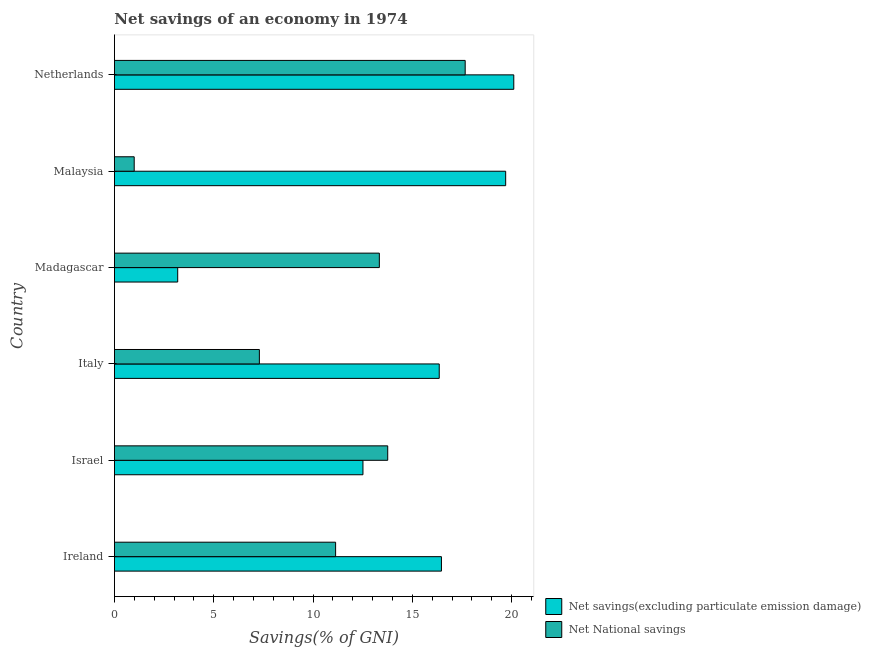How many groups of bars are there?
Offer a terse response. 6. Are the number of bars per tick equal to the number of legend labels?
Your answer should be very brief. Yes. How many bars are there on the 4th tick from the top?
Provide a short and direct response. 2. How many bars are there on the 6th tick from the bottom?
Provide a succinct answer. 2. What is the label of the 6th group of bars from the top?
Your response must be concise. Ireland. In how many cases, is the number of bars for a given country not equal to the number of legend labels?
Provide a short and direct response. 0. What is the net savings(excluding particulate emission damage) in Madagascar?
Make the answer very short. 3.19. Across all countries, what is the maximum net national savings?
Keep it short and to the point. 17.66. Across all countries, what is the minimum net national savings?
Keep it short and to the point. 1. In which country was the net savings(excluding particulate emission damage) maximum?
Offer a very short reply. Netherlands. In which country was the net national savings minimum?
Your response must be concise. Malaysia. What is the total net national savings in the graph?
Your answer should be compact. 64.18. What is the difference between the net savings(excluding particulate emission damage) in Ireland and that in Israel?
Keep it short and to the point. 3.95. What is the difference between the net savings(excluding particulate emission damage) in Malaysia and the net national savings in Ireland?
Offer a very short reply. 8.56. What is the average net savings(excluding particulate emission damage) per country?
Ensure brevity in your answer.  14.72. What is the difference between the net national savings and net savings(excluding particulate emission damage) in Israel?
Give a very brief answer. 1.25. In how many countries, is the net savings(excluding particulate emission damage) greater than 2 %?
Make the answer very short. 6. What is the ratio of the net savings(excluding particulate emission damage) in Ireland to that in Malaysia?
Give a very brief answer. 0.84. Is the net savings(excluding particulate emission damage) in Ireland less than that in Italy?
Keep it short and to the point. No. What is the difference between the highest and the second highest net savings(excluding particulate emission damage)?
Your answer should be compact. 0.41. What is the difference between the highest and the lowest net national savings?
Give a very brief answer. 16.66. What does the 1st bar from the top in Madagascar represents?
Ensure brevity in your answer.  Net National savings. What does the 2nd bar from the bottom in Netherlands represents?
Keep it short and to the point. Net National savings. Are the values on the major ticks of X-axis written in scientific E-notation?
Offer a very short reply. No. Does the graph contain any zero values?
Your answer should be compact. No. What is the title of the graph?
Provide a succinct answer. Net savings of an economy in 1974. Does "Primary completion rate" appear as one of the legend labels in the graph?
Your response must be concise. No. What is the label or title of the X-axis?
Provide a short and direct response. Savings(% of GNI). What is the Savings(% of GNI) in Net savings(excluding particulate emission damage) in Ireland?
Provide a short and direct response. 16.46. What is the Savings(% of GNI) in Net National savings in Ireland?
Give a very brief answer. 11.14. What is the Savings(% of GNI) in Net savings(excluding particulate emission damage) in Israel?
Offer a terse response. 12.51. What is the Savings(% of GNI) of Net National savings in Israel?
Your response must be concise. 13.76. What is the Savings(% of GNI) of Net savings(excluding particulate emission damage) in Italy?
Provide a short and direct response. 16.35. What is the Savings(% of GNI) of Net National savings in Italy?
Your response must be concise. 7.3. What is the Savings(% of GNI) in Net savings(excluding particulate emission damage) in Madagascar?
Your answer should be compact. 3.19. What is the Savings(% of GNI) in Net National savings in Madagascar?
Offer a terse response. 13.34. What is the Savings(% of GNI) in Net savings(excluding particulate emission damage) in Malaysia?
Give a very brief answer. 19.7. What is the Savings(% of GNI) in Net National savings in Malaysia?
Ensure brevity in your answer.  1. What is the Savings(% of GNI) in Net savings(excluding particulate emission damage) in Netherlands?
Provide a short and direct response. 20.1. What is the Savings(% of GNI) in Net National savings in Netherlands?
Provide a short and direct response. 17.66. Across all countries, what is the maximum Savings(% of GNI) in Net savings(excluding particulate emission damage)?
Your response must be concise. 20.1. Across all countries, what is the maximum Savings(% of GNI) of Net National savings?
Your response must be concise. 17.66. Across all countries, what is the minimum Savings(% of GNI) of Net savings(excluding particulate emission damage)?
Keep it short and to the point. 3.19. Across all countries, what is the minimum Savings(% of GNI) in Net National savings?
Ensure brevity in your answer.  1. What is the total Savings(% of GNI) of Net savings(excluding particulate emission damage) in the graph?
Provide a succinct answer. 88.31. What is the total Savings(% of GNI) in Net National savings in the graph?
Keep it short and to the point. 64.18. What is the difference between the Savings(% of GNI) in Net savings(excluding particulate emission damage) in Ireland and that in Israel?
Your answer should be very brief. 3.95. What is the difference between the Savings(% of GNI) of Net National savings in Ireland and that in Israel?
Ensure brevity in your answer.  -2.62. What is the difference between the Savings(% of GNI) in Net savings(excluding particulate emission damage) in Ireland and that in Italy?
Provide a short and direct response. 0.11. What is the difference between the Savings(% of GNI) of Net National savings in Ireland and that in Italy?
Your answer should be very brief. 3.84. What is the difference between the Savings(% of GNI) of Net savings(excluding particulate emission damage) in Ireland and that in Madagascar?
Ensure brevity in your answer.  13.28. What is the difference between the Savings(% of GNI) in Net National savings in Ireland and that in Madagascar?
Your answer should be compact. -2.2. What is the difference between the Savings(% of GNI) of Net savings(excluding particulate emission damage) in Ireland and that in Malaysia?
Your response must be concise. -3.23. What is the difference between the Savings(% of GNI) of Net National savings in Ireland and that in Malaysia?
Your answer should be compact. 10.14. What is the difference between the Savings(% of GNI) in Net savings(excluding particulate emission damage) in Ireland and that in Netherlands?
Keep it short and to the point. -3.64. What is the difference between the Savings(% of GNI) of Net National savings in Ireland and that in Netherlands?
Provide a succinct answer. -6.52. What is the difference between the Savings(% of GNI) in Net savings(excluding particulate emission damage) in Israel and that in Italy?
Your response must be concise. -3.84. What is the difference between the Savings(% of GNI) in Net National savings in Israel and that in Italy?
Your response must be concise. 6.46. What is the difference between the Savings(% of GNI) in Net savings(excluding particulate emission damage) in Israel and that in Madagascar?
Ensure brevity in your answer.  9.33. What is the difference between the Savings(% of GNI) in Net National savings in Israel and that in Madagascar?
Give a very brief answer. 0.42. What is the difference between the Savings(% of GNI) of Net savings(excluding particulate emission damage) in Israel and that in Malaysia?
Keep it short and to the point. -7.18. What is the difference between the Savings(% of GNI) of Net National savings in Israel and that in Malaysia?
Keep it short and to the point. 12.76. What is the difference between the Savings(% of GNI) in Net savings(excluding particulate emission damage) in Israel and that in Netherlands?
Your answer should be very brief. -7.59. What is the difference between the Savings(% of GNI) in Net National savings in Israel and that in Netherlands?
Make the answer very short. -3.9. What is the difference between the Savings(% of GNI) of Net savings(excluding particulate emission damage) in Italy and that in Madagascar?
Provide a succinct answer. 13.17. What is the difference between the Savings(% of GNI) in Net National savings in Italy and that in Madagascar?
Provide a succinct answer. -6.04. What is the difference between the Savings(% of GNI) in Net savings(excluding particulate emission damage) in Italy and that in Malaysia?
Keep it short and to the point. -3.34. What is the difference between the Savings(% of GNI) in Net National savings in Italy and that in Malaysia?
Keep it short and to the point. 6.3. What is the difference between the Savings(% of GNI) of Net savings(excluding particulate emission damage) in Italy and that in Netherlands?
Provide a short and direct response. -3.75. What is the difference between the Savings(% of GNI) in Net National savings in Italy and that in Netherlands?
Provide a succinct answer. -10.36. What is the difference between the Savings(% of GNI) in Net savings(excluding particulate emission damage) in Madagascar and that in Malaysia?
Give a very brief answer. -16.51. What is the difference between the Savings(% of GNI) of Net National savings in Madagascar and that in Malaysia?
Your answer should be very brief. 12.34. What is the difference between the Savings(% of GNI) in Net savings(excluding particulate emission damage) in Madagascar and that in Netherlands?
Ensure brevity in your answer.  -16.92. What is the difference between the Savings(% of GNI) in Net National savings in Madagascar and that in Netherlands?
Give a very brief answer. -4.32. What is the difference between the Savings(% of GNI) of Net savings(excluding particulate emission damage) in Malaysia and that in Netherlands?
Give a very brief answer. -0.41. What is the difference between the Savings(% of GNI) in Net National savings in Malaysia and that in Netherlands?
Offer a terse response. -16.66. What is the difference between the Savings(% of GNI) of Net savings(excluding particulate emission damage) in Ireland and the Savings(% of GNI) of Net National savings in Israel?
Provide a succinct answer. 2.71. What is the difference between the Savings(% of GNI) in Net savings(excluding particulate emission damage) in Ireland and the Savings(% of GNI) in Net National savings in Italy?
Keep it short and to the point. 9.17. What is the difference between the Savings(% of GNI) of Net savings(excluding particulate emission damage) in Ireland and the Savings(% of GNI) of Net National savings in Madagascar?
Your answer should be very brief. 3.13. What is the difference between the Savings(% of GNI) of Net savings(excluding particulate emission damage) in Ireland and the Savings(% of GNI) of Net National savings in Malaysia?
Keep it short and to the point. 15.47. What is the difference between the Savings(% of GNI) of Net savings(excluding particulate emission damage) in Ireland and the Savings(% of GNI) of Net National savings in Netherlands?
Your response must be concise. -1.2. What is the difference between the Savings(% of GNI) in Net savings(excluding particulate emission damage) in Israel and the Savings(% of GNI) in Net National savings in Italy?
Make the answer very short. 5.21. What is the difference between the Savings(% of GNI) of Net savings(excluding particulate emission damage) in Israel and the Savings(% of GNI) of Net National savings in Madagascar?
Provide a succinct answer. -0.83. What is the difference between the Savings(% of GNI) of Net savings(excluding particulate emission damage) in Israel and the Savings(% of GNI) of Net National savings in Malaysia?
Make the answer very short. 11.52. What is the difference between the Savings(% of GNI) in Net savings(excluding particulate emission damage) in Israel and the Savings(% of GNI) in Net National savings in Netherlands?
Your answer should be compact. -5.15. What is the difference between the Savings(% of GNI) in Net savings(excluding particulate emission damage) in Italy and the Savings(% of GNI) in Net National savings in Madagascar?
Ensure brevity in your answer.  3.01. What is the difference between the Savings(% of GNI) in Net savings(excluding particulate emission damage) in Italy and the Savings(% of GNI) in Net National savings in Malaysia?
Your answer should be very brief. 15.36. What is the difference between the Savings(% of GNI) of Net savings(excluding particulate emission damage) in Italy and the Savings(% of GNI) of Net National savings in Netherlands?
Ensure brevity in your answer.  -1.31. What is the difference between the Savings(% of GNI) in Net savings(excluding particulate emission damage) in Madagascar and the Savings(% of GNI) in Net National savings in Malaysia?
Provide a short and direct response. 2.19. What is the difference between the Savings(% of GNI) of Net savings(excluding particulate emission damage) in Madagascar and the Savings(% of GNI) of Net National savings in Netherlands?
Keep it short and to the point. -14.47. What is the difference between the Savings(% of GNI) of Net savings(excluding particulate emission damage) in Malaysia and the Savings(% of GNI) of Net National savings in Netherlands?
Offer a terse response. 2.04. What is the average Savings(% of GNI) in Net savings(excluding particulate emission damage) per country?
Give a very brief answer. 14.72. What is the average Savings(% of GNI) of Net National savings per country?
Give a very brief answer. 10.7. What is the difference between the Savings(% of GNI) in Net savings(excluding particulate emission damage) and Savings(% of GNI) in Net National savings in Ireland?
Offer a terse response. 5.33. What is the difference between the Savings(% of GNI) in Net savings(excluding particulate emission damage) and Savings(% of GNI) in Net National savings in Israel?
Give a very brief answer. -1.25. What is the difference between the Savings(% of GNI) in Net savings(excluding particulate emission damage) and Savings(% of GNI) in Net National savings in Italy?
Your answer should be compact. 9.05. What is the difference between the Savings(% of GNI) in Net savings(excluding particulate emission damage) and Savings(% of GNI) in Net National savings in Madagascar?
Offer a terse response. -10.15. What is the difference between the Savings(% of GNI) of Net savings(excluding particulate emission damage) and Savings(% of GNI) of Net National savings in Malaysia?
Your answer should be compact. 18.7. What is the difference between the Savings(% of GNI) of Net savings(excluding particulate emission damage) and Savings(% of GNI) of Net National savings in Netherlands?
Your response must be concise. 2.45. What is the ratio of the Savings(% of GNI) of Net savings(excluding particulate emission damage) in Ireland to that in Israel?
Provide a succinct answer. 1.32. What is the ratio of the Savings(% of GNI) of Net National savings in Ireland to that in Israel?
Offer a terse response. 0.81. What is the ratio of the Savings(% of GNI) in Net savings(excluding particulate emission damage) in Ireland to that in Italy?
Offer a very short reply. 1.01. What is the ratio of the Savings(% of GNI) in Net National savings in Ireland to that in Italy?
Offer a terse response. 1.53. What is the ratio of the Savings(% of GNI) in Net savings(excluding particulate emission damage) in Ireland to that in Madagascar?
Give a very brief answer. 5.17. What is the ratio of the Savings(% of GNI) of Net National savings in Ireland to that in Madagascar?
Provide a succinct answer. 0.83. What is the ratio of the Savings(% of GNI) of Net savings(excluding particulate emission damage) in Ireland to that in Malaysia?
Give a very brief answer. 0.84. What is the ratio of the Savings(% of GNI) in Net National savings in Ireland to that in Malaysia?
Provide a short and direct response. 11.19. What is the ratio of the Savings(% of GNI) in Net savings(excluding particulate emission damage) in Ireland to that in Netherlands?
Your response must be concise. 0.82. What is the ratio of the Savings(% of GNI) of Net National savings in Ireland to that in Netherlands?
Your response must be concise. 0.63. What is the ratio of the Savings(% of GNI) in Net savings(excluding particulate emission damage) in Israel to that in Italy?
Provide a short and direct response. 0.77. What is the ratio of the Savings(% of GNI) of Net National savings in Israel to that in Italy?
Offer a terse response. 1.89. What is the ratio of the Savings(% of GNI) in Net savings(excluding particulate emission damage) in Israel to that in Madagascar?
Keep it short and to the point. 3.93. What is the ratio of the Savings(% of GNI) of Net National savings in Israel to that in Madagascar?
Your answer should be very brief. 1.03. What is the ratio of the Savings(% of GNI) of Net savings(excluding particulate emission damage) in Israel to that in Malaysia?
Make the answer very short. 0.64. What is the ratio of the Savings(% of GNI) in Net National savings in Israel to that in Malaysia?
Give a very brief answer. 13.82. What is the ratio of the Savings(% of GNI) of Net savings(excluding particulate emission damage) in Israel to that in Netherlands?
Offer a very short reply. 0.62. What is the ratio of the Savings(% of GNI) of Net National savings in Israel to that in Netherlands?
Your response must be concise. 0.78. What is the ratio of the Savings(% of GNI) of Net savings(excluding particulate emission damage) in Italy to that in Madagascar?
Provide a succinct answer. 5.13. What is the ratio of the Savings(% of GNI) of Net National savings in Italy to that in Madagascar?
Offer a terse response. 0.55. What is the ratio of the Savings(% of GNI) of Net savings(excluding particulate emission damage) in Italy to that in Malaysia?
Ensure brevity in your answer.  0.83. What is the ratio of the Savings(% of GNI) in Net National savings in Italy to that in Malaysia?
Provide a succinct answer. 7.33. What is the ratio of the Savings(% of GNI) of Net savings(excluding particulate emission damage) in Italy to that in Netherlands?
Offer a very short reply. 0.81. What is the ratio of the Savings(% of GNI) in Net National savings in Italy to that in Netherlands?
Make the answer very short. 0.41. What is the ratio of the Savings(% of GNI) in Net savings(excluding particulate emission damage) in Madagascar to that in Malaysia?
Offer a terse response. 0.16. What is the ratio of the Savings(% of GNI) in Net savings(excluding particulate emission damage) in Madagascar to that in Netherlands?
Ensure brevity in your answer.  0.16. What is the ratio of the Savings(% of GNI) of Net National savings in Madagascar to that in Netherlands?
Your answer should be very brief. 0.76. What is the ratio of the Savings(% of GNI) in Net savings(excluding particulate emission damage) in Malaysia to that in Netherlands?
Give a very brief answer. 0.98. What is the ratio of the Savings(% of GNI) of Net National savings in Malaysia to that in Netherlands?
Keep it short and to the point. 0.06. What is the difference between the highest and the second highest Savings(% of GNI) of Net savings(excluding particulate emission damage)?
Give a very brief answer. 0.41. What is the difference between the highest and the second highest Savings(% of GNI) in Net National savings?
Give a very brief answer. 3.9. What is the difference between the highest and the lowest Savings(% of GNI) in Net savings(excluding particulate emission damage)?
Provide a succinct answer. 16.92. What is the difference between the highest and the lowest Savings(% of GNI) in Net National savings?
Offer a very short reply. 16.66. 